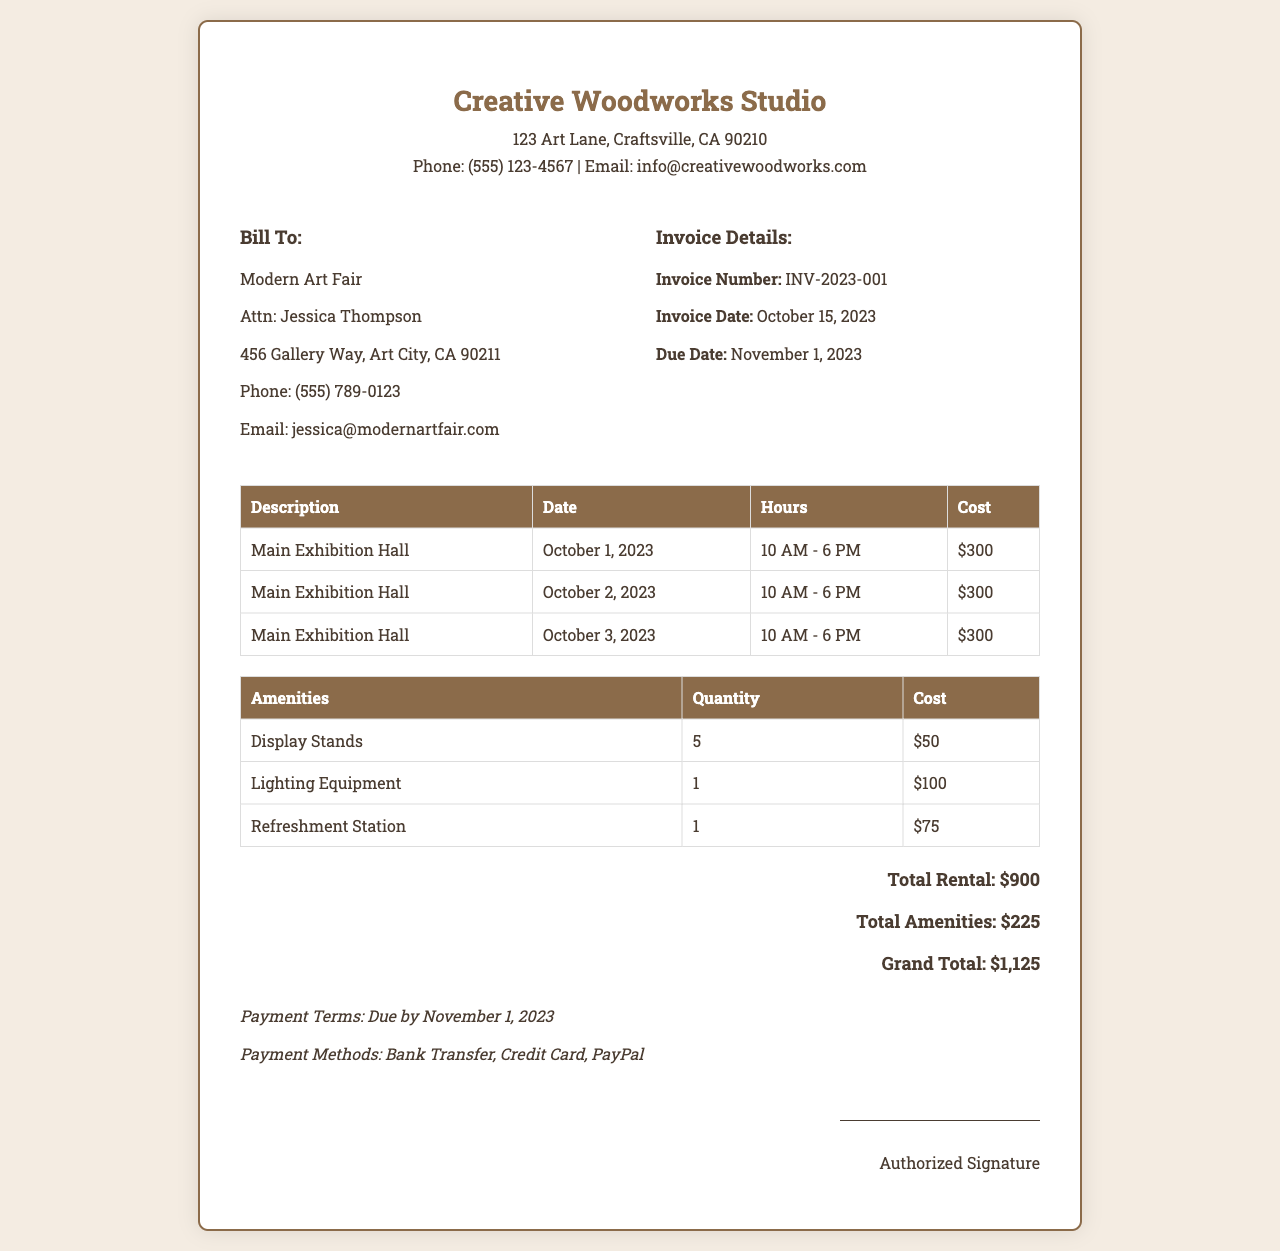What is the invoice number? The invoice number is clearly stated in the document.
Answer: INV-2023-001 What is the total rental cost? The total rental cost is specified in the total section of the invoice.
Answer: $900 Who is the authorized signature for this invoice? The document mentions an authorized signature at the end without giving a specific name.
Answer: Authorized Signature What is the due date for this invoice? The due date is mentioned in the invoice details section.
Answer: November 1, 2023 How many days was the studio rented? The invoice lists three dates of rental, indicating how many days it was used.
Answer: 3 days What amenities were provided? The amenities section of the document lists several items provided during the exhibition.
Answer: Display Stands, Lighting Equipment, Refreshment Station What is the grand total for the invoice? The grand total summarizes all related costs at the end of the document.
Answer: $1,125 What are the payment methods stated? The payment terms section includes various methods for payment.
Answer: Bank Transfer, Credit Card, PayPal How many hours were rented for each day? The document indicates the hours of rental for each listed date.
Answer: 8 hours 